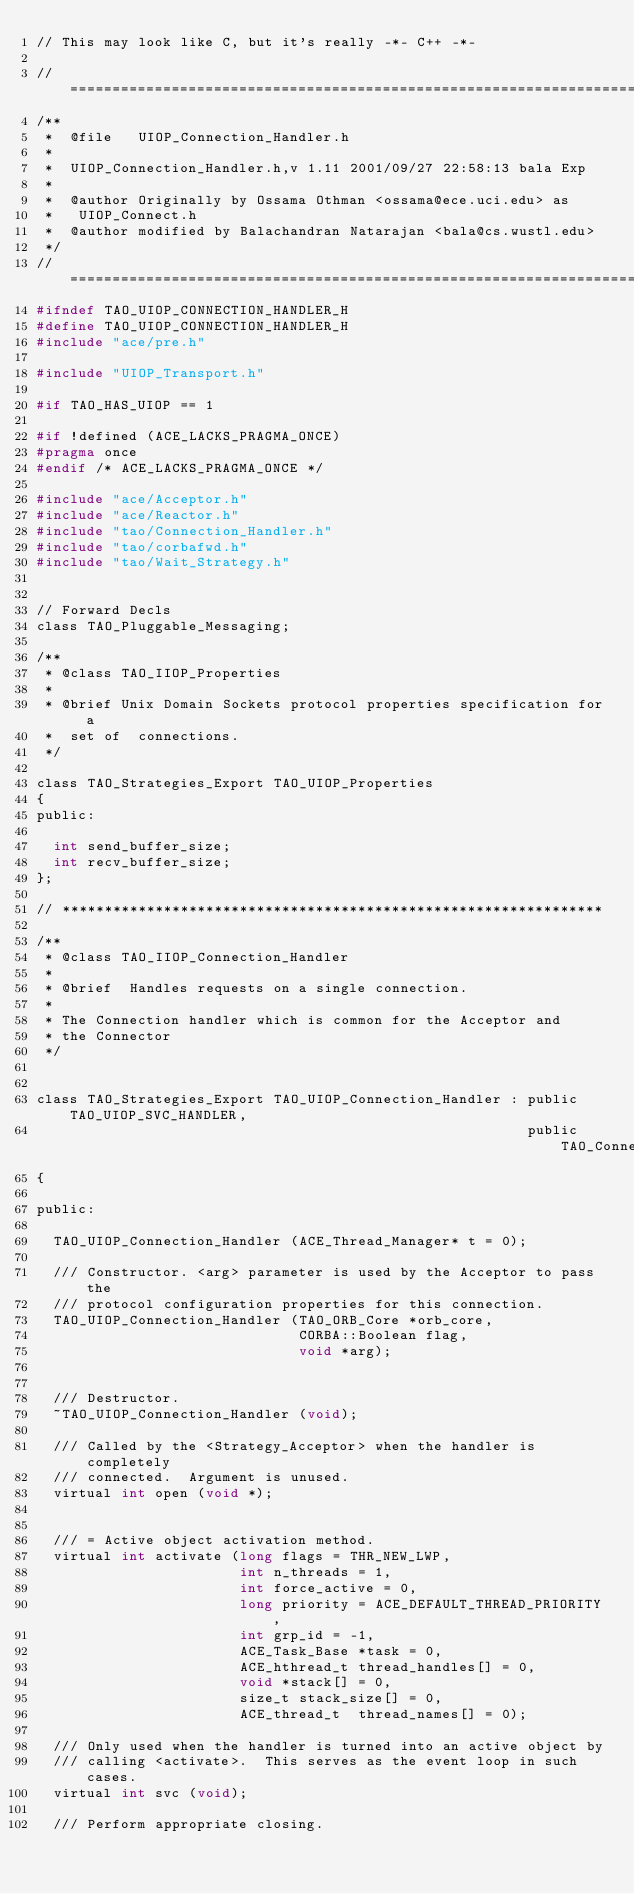Convert code to text. <code><loc_0><loc_0><loc_500><loc_500><_C_>// This may look like C, but it's really -*- C++ -*-

// ===================================================================
/**
 *  @file   UIOP_Connection_Handler.h
 *
 *  UIOP_Connection_Handler.h,v 1.11 2001/09/27 22:58:13 bala Exp
 *
 *  @author Originally by Ossama Othman <ossama@ece.uci.edu> as
 *   UIOP_Connect.h
 *  @author modified by Balachandran Natarajan <bala@cs.wustl.edu>
 */
// ===================================================================
#ifndef TAO_UIOP_CONNECTION_HANDLER_H
#define TAO_UIOP_CONNECTION_HANDLER_H
#include "ace/pre.h"

#include "UIOP_Transport.h"

#if TAO_HAS_UIOP == 1

#if !defined (ACE_LACKS_PRAGMA_ONCE)
#pragma once
#endif /* ACE_LACKS_PRAGMA_ONCE */

#include "ace/Acceptor.h"
#include "ace/Reactor.h"
#include "tao/Connection_Handler.h"
#include "tao/corbafwd.h"
#include "tao/Wait_Strategy.h"


// Forward Decls
class TAO_Pluggable_Messaging;

/**
 * @class TAO_IIOP_Properties
 *
 * @brief Unix Domain Sockets protocol properties specification for a
 *  set of  connections.
 */

class TAO_Strategies_Export TAO_UIOP_Properties
{
public:

  int send_buffer_size;
  int recv_buffer_size;
};

// ****************************************************************

/**
 * @class TAO_IIOP_Connection_Handler
 *
 * @brief  Handles requests on a single connection.
 *
 * The Connection handler which is common for the Acceptor and
 * the Connector
 */


class TAO_Strategies_Export TAO_UIOP_Connection_Handler : public TAO_UIOP_SVC_HANDLER,
                                                          public TAO_Connection_Handler
{

public:

  TAO_UIOP_Connection_Handler (ACE_Thread_Manager* t = 0);

  /// Constructor. <arg> parameter is used by the Acceptor to pass the
  /// protocol configuration properties for this connection.
  TAO_UIOP_Connection_Handler (TAO_ORB_Core *orb_core,
                               CORBA::Boolean flag,
                               void *arg);


  /// Destructor.
  ~TAO_UIOP_Connection_Handler (void);

  /// Called by the <Strategy_Acceptor> when the handler is completely
  /// connected.  Argument is unused.
  virtual int open (void *);


  /// = Active object activation method.
  virtual int activate (long flags = THR_NEW_LWP,
                        int n_threads = 1,
                        int force_active = 0,
                        long priority = ACE_DEFAULT_THREAD_PRIORITY,
                        int grp_id = -1,
                        ACE_Task_Base *task = 0,
                        ACE_hthread_t thread_handles[] = 0,
                        void *stack[] = 0,
                        size_t stack_size[] = 0,
                        ACE_thread_t  thread_names[] = 0);

  /// Only used when the handler is turned into an active object by
  /// calling <activate>.  This serves as the event loop in such cases.
  virtual int svc (void);

  /// Perform appropriate closing.</code> 